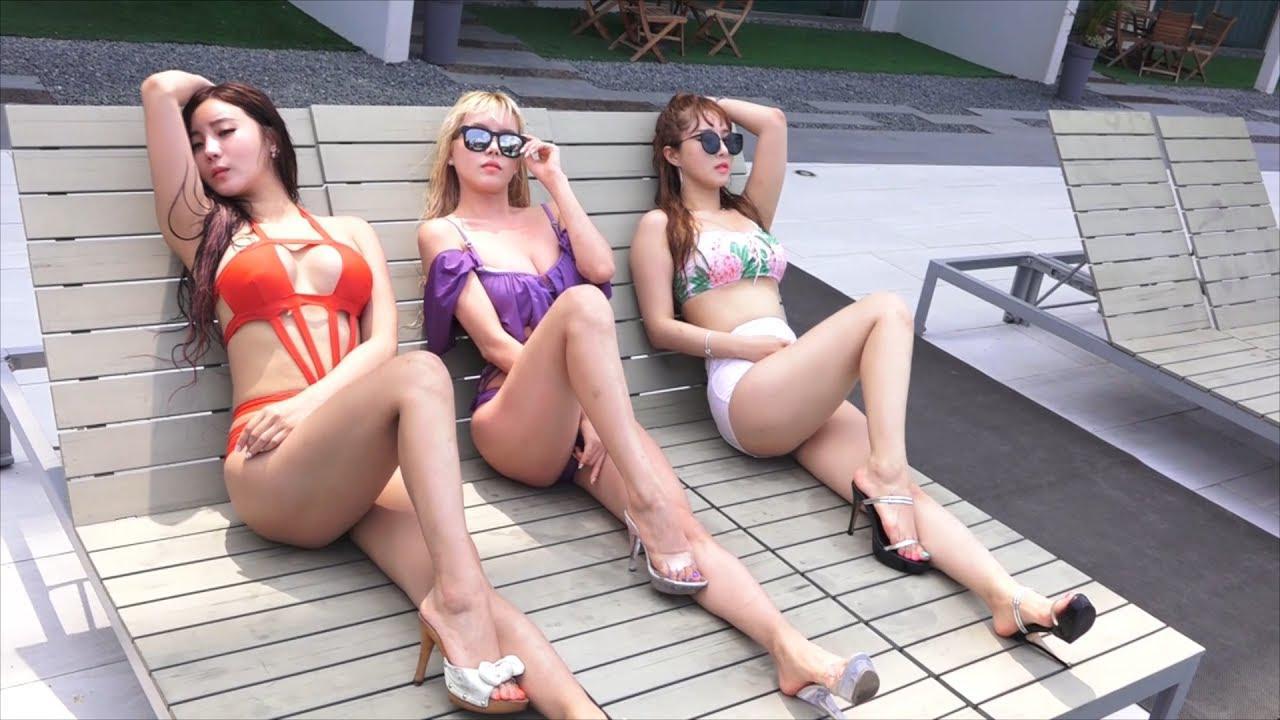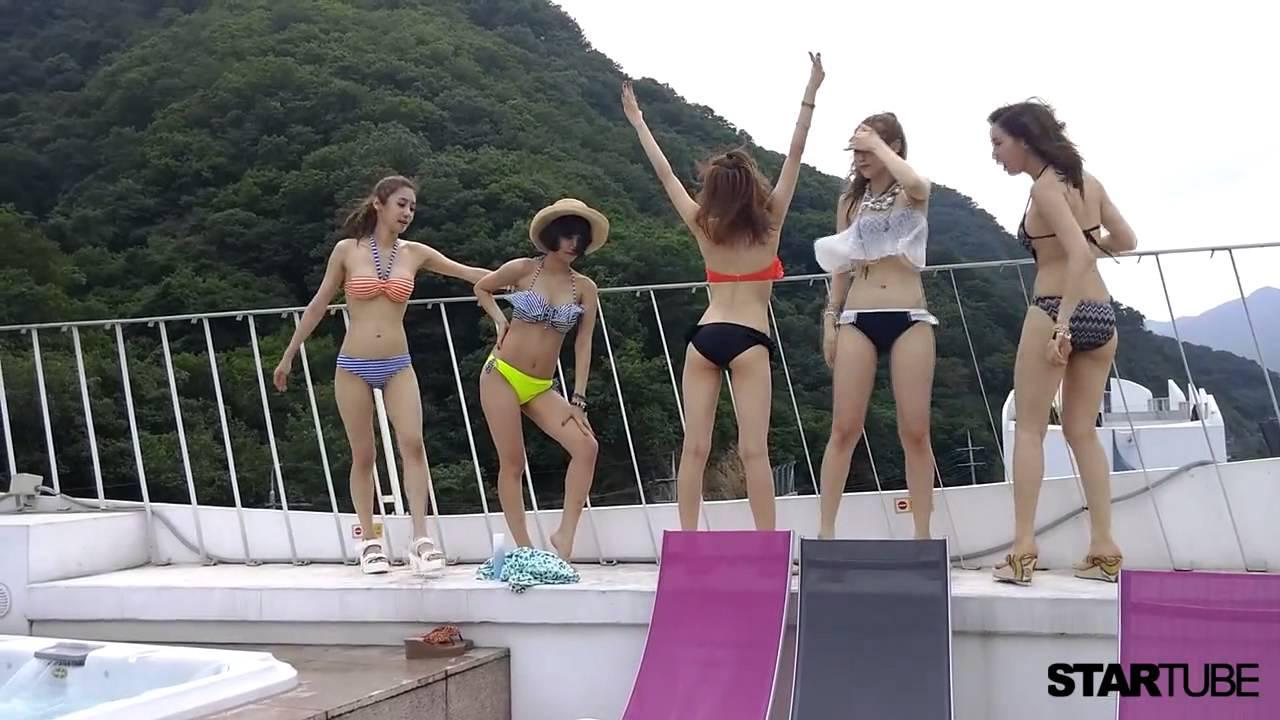The first image is the image on the left, the second image is the image on the right. For the images shown, is this caption "The bikini-clad girls are wearing high heels in the pool." true? Answer yes or no. No. The first image is the image on the left, the second image is the image on the right. Considering the images on both sides, is "The left and right image contains the same number of women in bikinis." valid? Answer yes or no. No. 